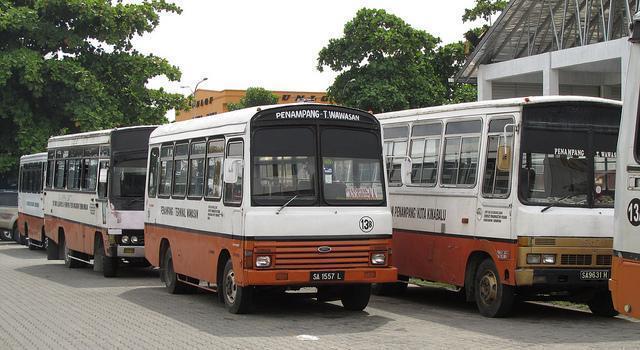How many buses?
Give a very brief answer. 5. How many people are in the photo?
Give a very brief answer. 0. How many buses are visible?
Give a very brief answer. 5. How many hot dogs in total?
Give a very brief answer. 0. 